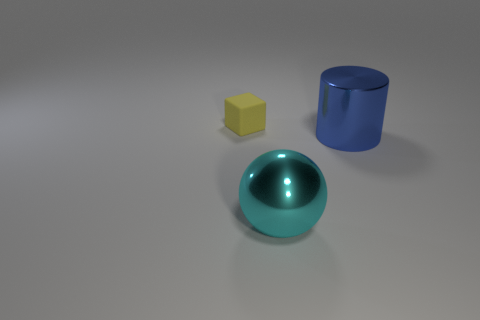Add 3 tiny gray matte balls. How many objects exist? 6 Subtract all blocks. How many objects are left? 2 Subtract all brown balls. Subtract all shiny things. How many objects are left? 1 Add 3 big metallic things. How many big metallic things are left? 5 Add 1 rubber objects. How many rubber objects exist? 2 Subtract 0 green spheres. How many objects are left? 3 Subtract 1 cylinders. How many cylinders are left? 0 Subtract all purple balls. Subtract all yellow cylinders. How many balls are left? 1 Subtract all red blocks. How many red cylinders are left? 0 